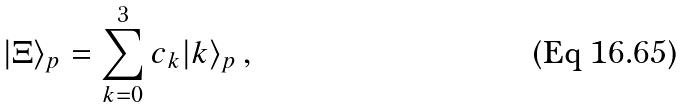Convert formula to latex. <formula><loc_0><loc_0><loc_500><loc_500>| \Xi \rangle _ { p } = \sum _ { k = 0 } ^ { 3 } c _ { k } | k \rangle _ { p } \, ,</formula> 